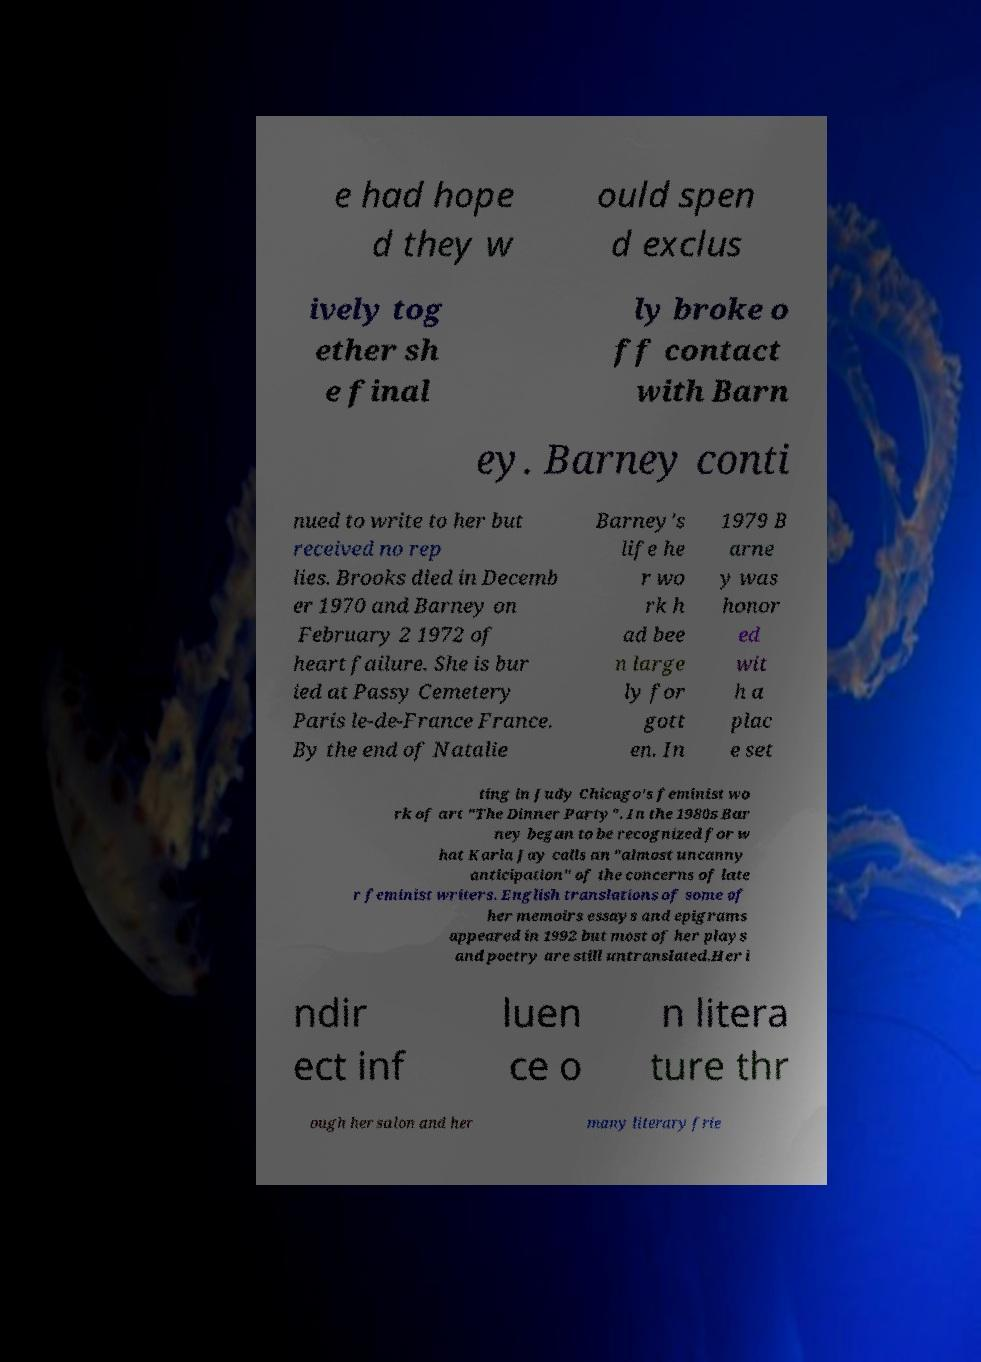There's text embedded in this image that I need extracted. Can you transcribe it verbatim? e had hope d they w ould spen d exclus ively tog ether sh e final ly broke o ff contact with Barn ey. Barney conti nued to write to her but received no rep lies. Brooks died in Decemb er 1970 and Barney on February 2 1972 of heart failure. She is bur ied at Passy Cemetery Paris le-de-France France. By the end of Natalie Barney's life he r wo rk h ad bee n large ly for gott en. In 1979 B arne y was honor ed wit h a plac e set ting in Judy Chicago's feminist wo rk of art "The Dinner Party". In the 1980s Bar ney began to be recognized for w hat Karla Jay calls an "almost uncanny anticipation" of the concerns of late r feminist writers. English translations of some of her memoirs essays and epigrams appeared in 1992 but most of her plays and poetry are still untranslated.Her i ndir ect inf luen ce o n litera ture thr ough her salon and her many literary frie 